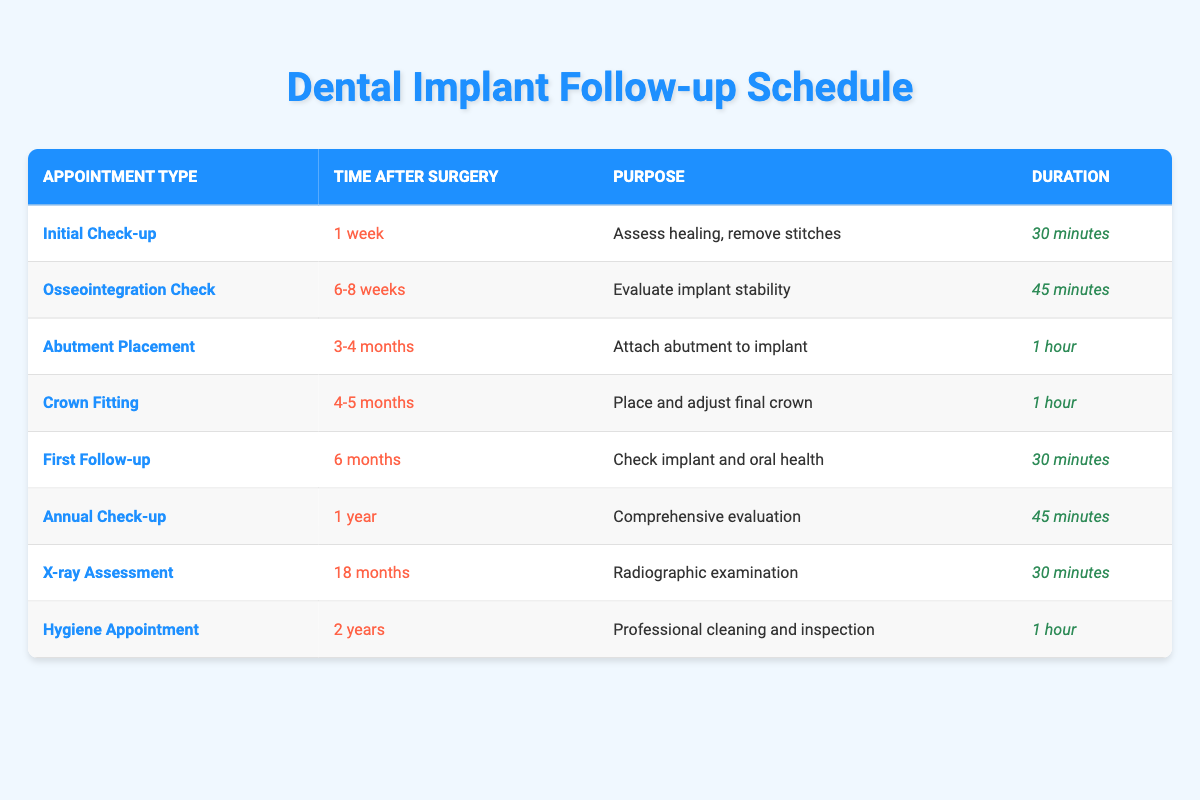What is the purpose of the Initial Check-up appointment? According to the table, the purpose of the Initial Check-up appointment is to assess healing and remove stitches. This is specifically mentioned under the "Purpose" column for that appointment type.
Answer: Assess healing, remove stitches How long does the Osseointegration Check appointment last? The duration for the Osseointegration Check appointment is listed in the table under the "Duration" column as 45 minutes.
Answer: 45 minutes Is the Crown Fitting appointment scheduled before or after the Abutment Placement? The table shows that the Crown Fitting appointment is scheduled for 4-5 months after surgery, whereas the Abutment Placement is at 3-4 months after surgery. Since 4-5 months comes after 3-4 months, the Crown Fitting is scheduled after the Abutment Placement.
Answer: After What is the total time between the Initial Check-up and the First Follow-up appointment? The Initial Check-up is at 1 week and the First Follow-up appointment is at 6 months. To calculate the total time: 6 months = approximately 26 weeks. So, the time between is 26 weeks - 1 week = 25 weeks.
Answer: 25 weeks Which appointment has the longest duration? By reviewing the "Duration" column, both the Abutment Placement and Crown Fitting appointments last for 1 hour. This is the longest duration listed compared to other appointments, which range from 30 minutes to 45 minutes.
Answer: 1 hour Is there a follow-up appointment directly after the X-ray Assessment? The table shows that the X-ray Assessment is scheduled at 18 months, followed by the Hygiene Appointment at 2 years. Since there is a gap of 6 months between these two appointments, there is no follow-up appointment directly after the X-ray Assessment.
Answer: No What is the average duration of all the appointments listed? To calculate the average duration, sum the durations: 30 + 45 + 60 + 60 + 30 + 45 + 30 + 60 = 360 minutes. There are 8 appointments, so the average is 360 minutes / 8 = 45 minutes.
Answer: 45 minutes Which appointment takes place the latest after surgery? The Hygiene Appointment is scheduled for 2 years after surgery, which is the latest appointment when compared to all others in the table.
Answer: Hygiene Appointment 